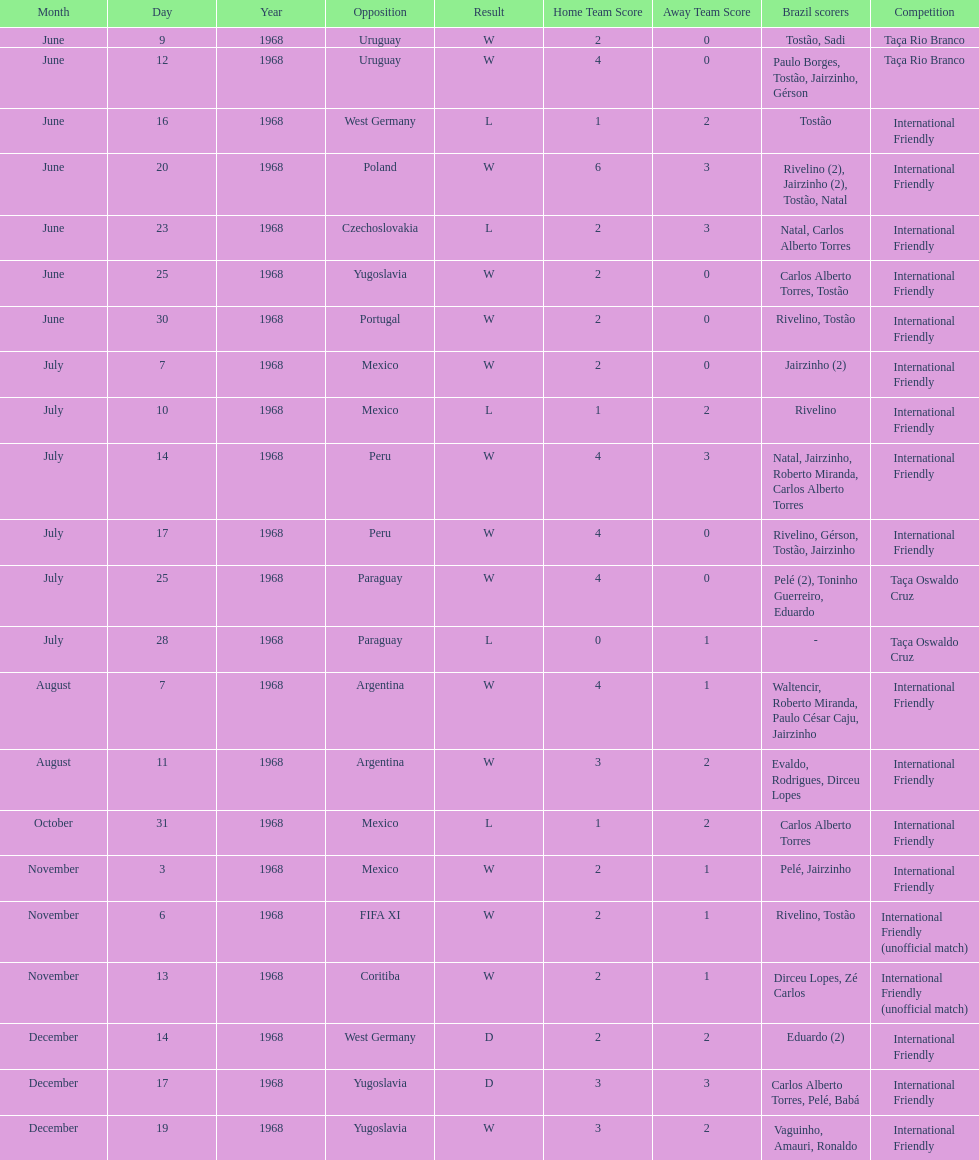What year has the highest scoring game? 1968. 